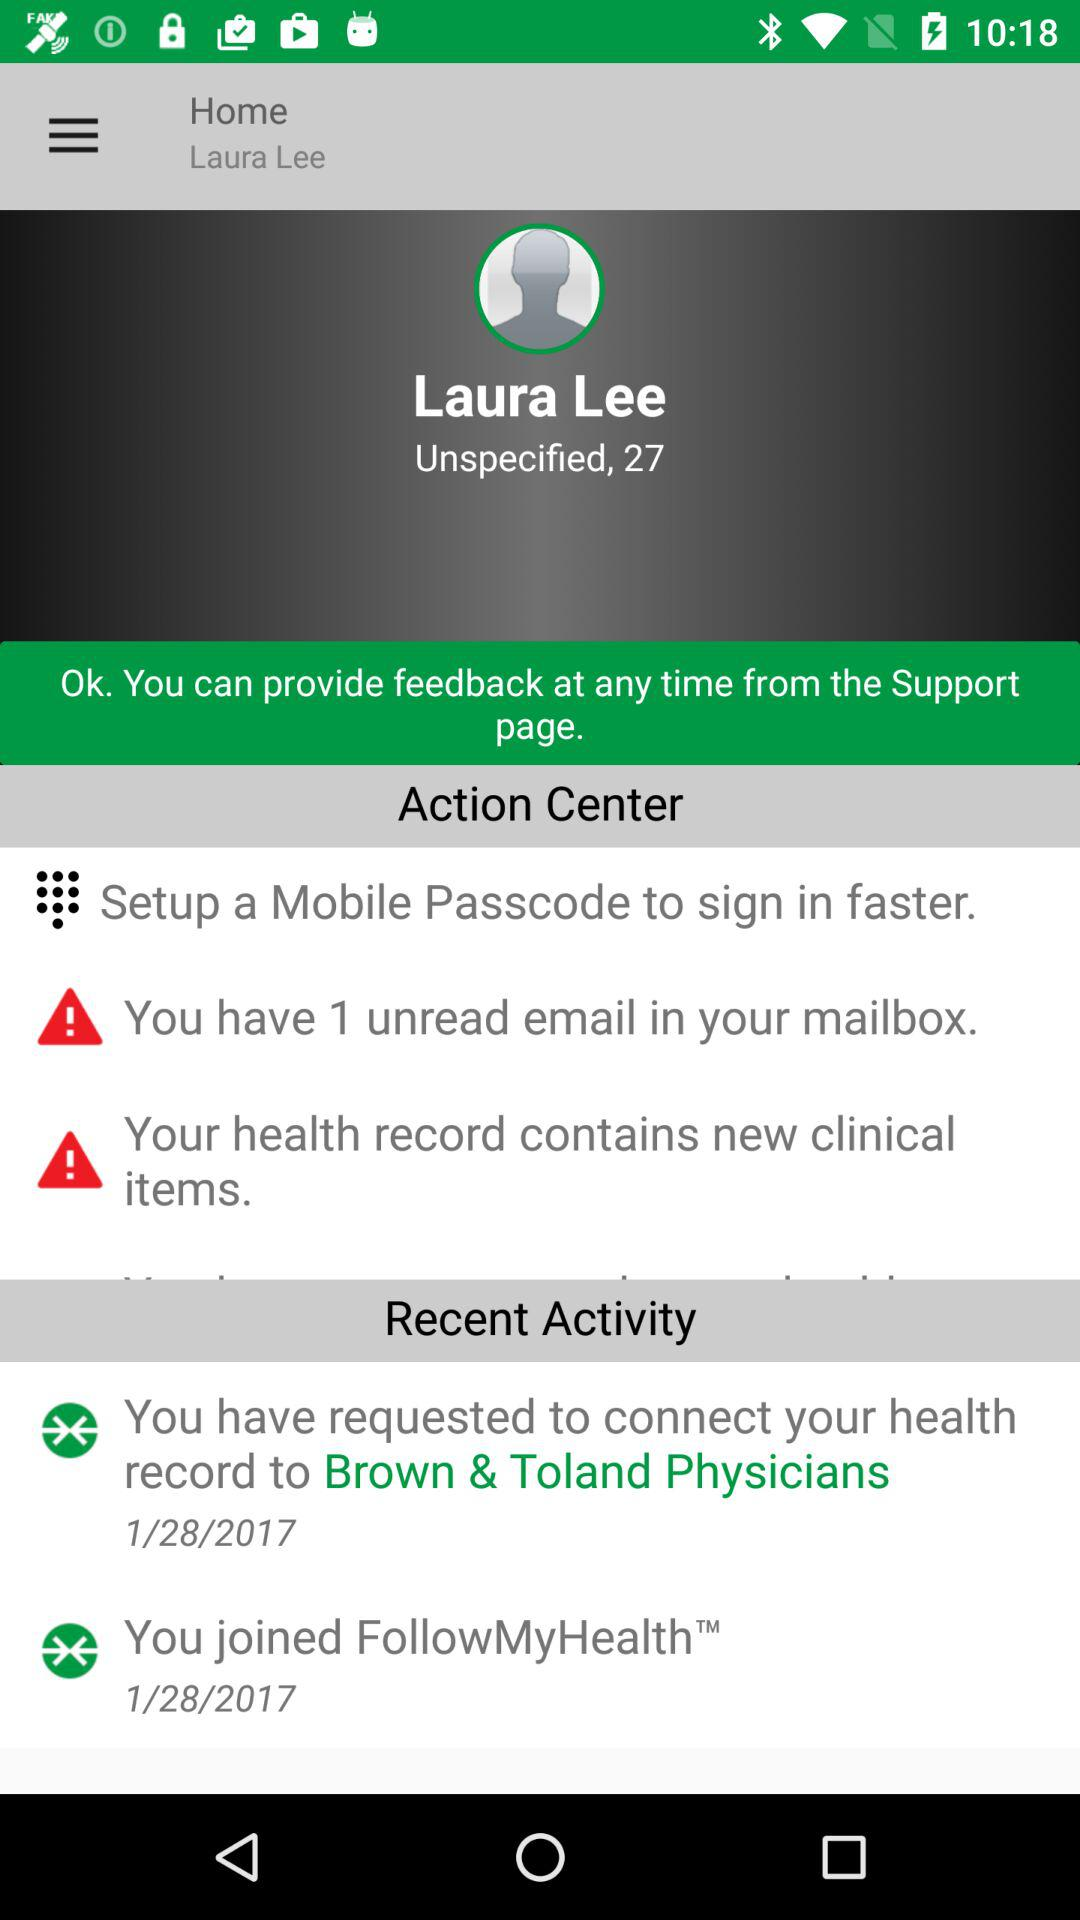What is the given date in "You joined FollowMyHealth™"? The given date in "You joined FollowMyHealth™" is January 28, 2017. 